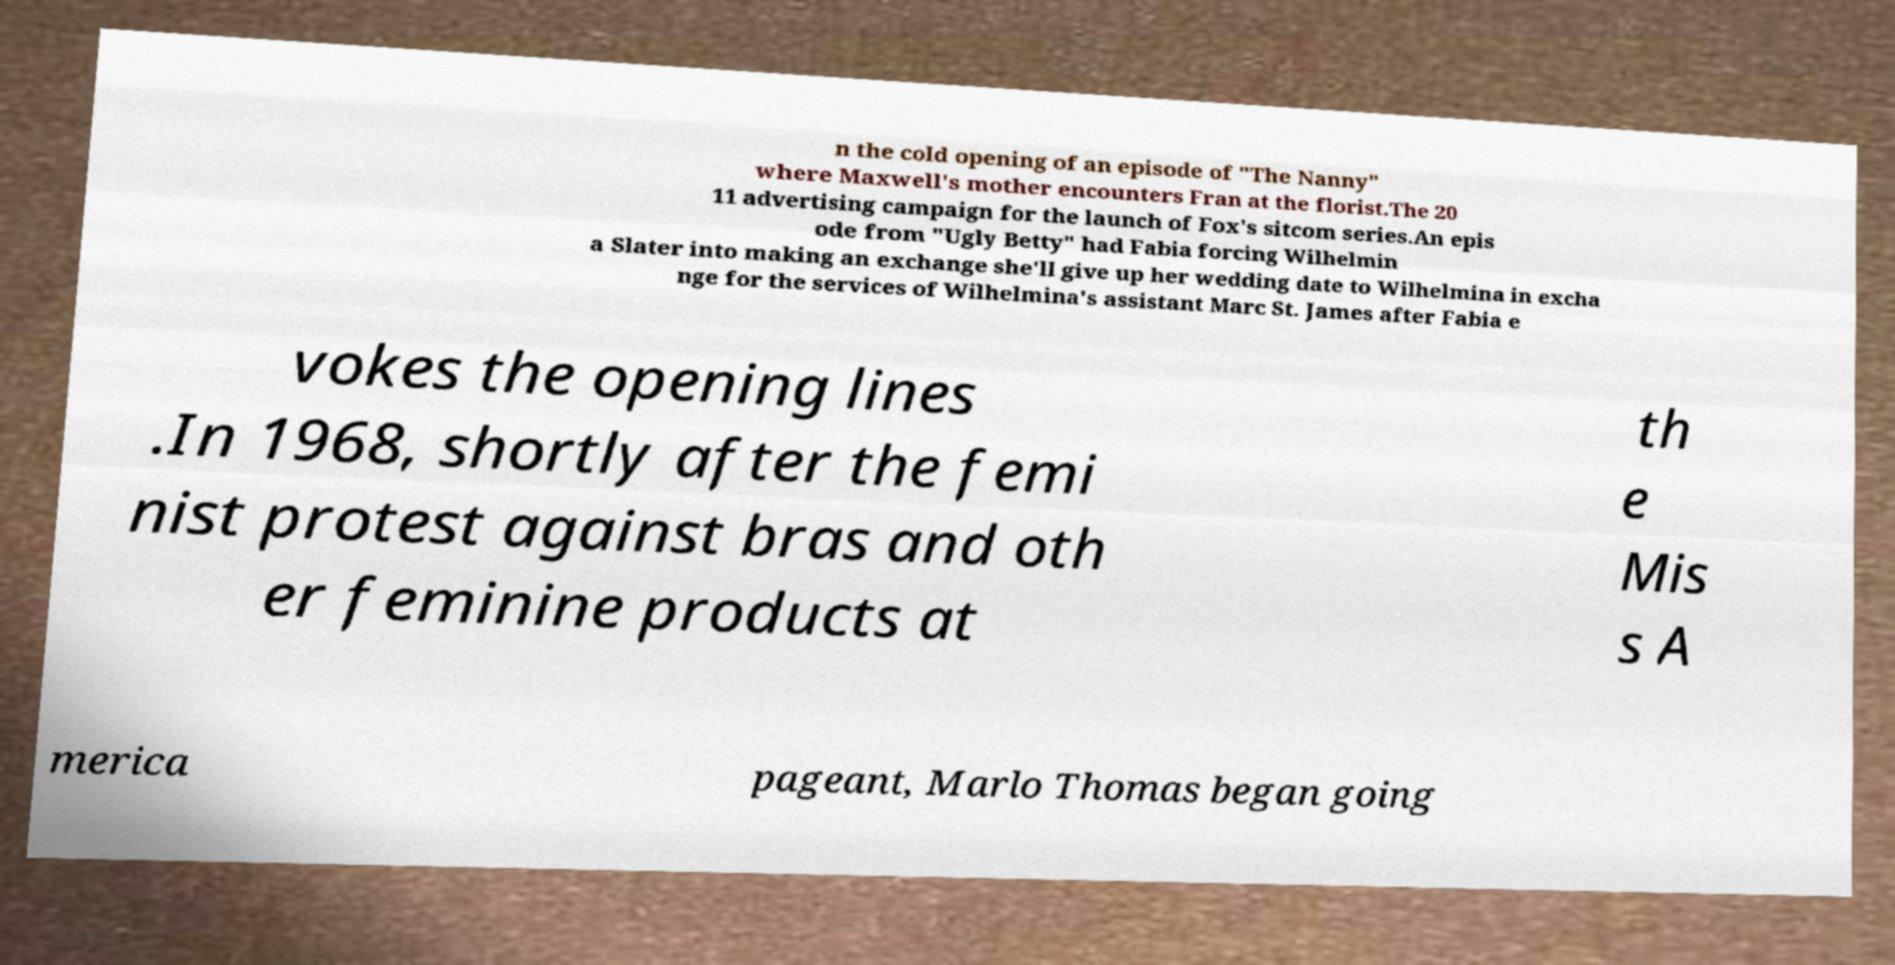What messages or text are displayed in this image? I need them in a readable, typed format. n the cold opening of an episode of "The Nanny" where Maxwell's mother encounters Fran at the florist.The 20 11 advertising campaign for the launch of Fox's sitcom series.An epis ode from "Ugly Betty" had Fabia forcing Wilhelmin a Slater into making an exchange she'll give up her wedding date to Wilhelmina in excha nge for the services of Wilhelmina's assistant Marc St. James after Fabia e vokes the opening lines .In 1968, shortly after the femi nist protest against bras and oth er feminine products at th e Mis s A merica pageant, Marlo Thomas began going 